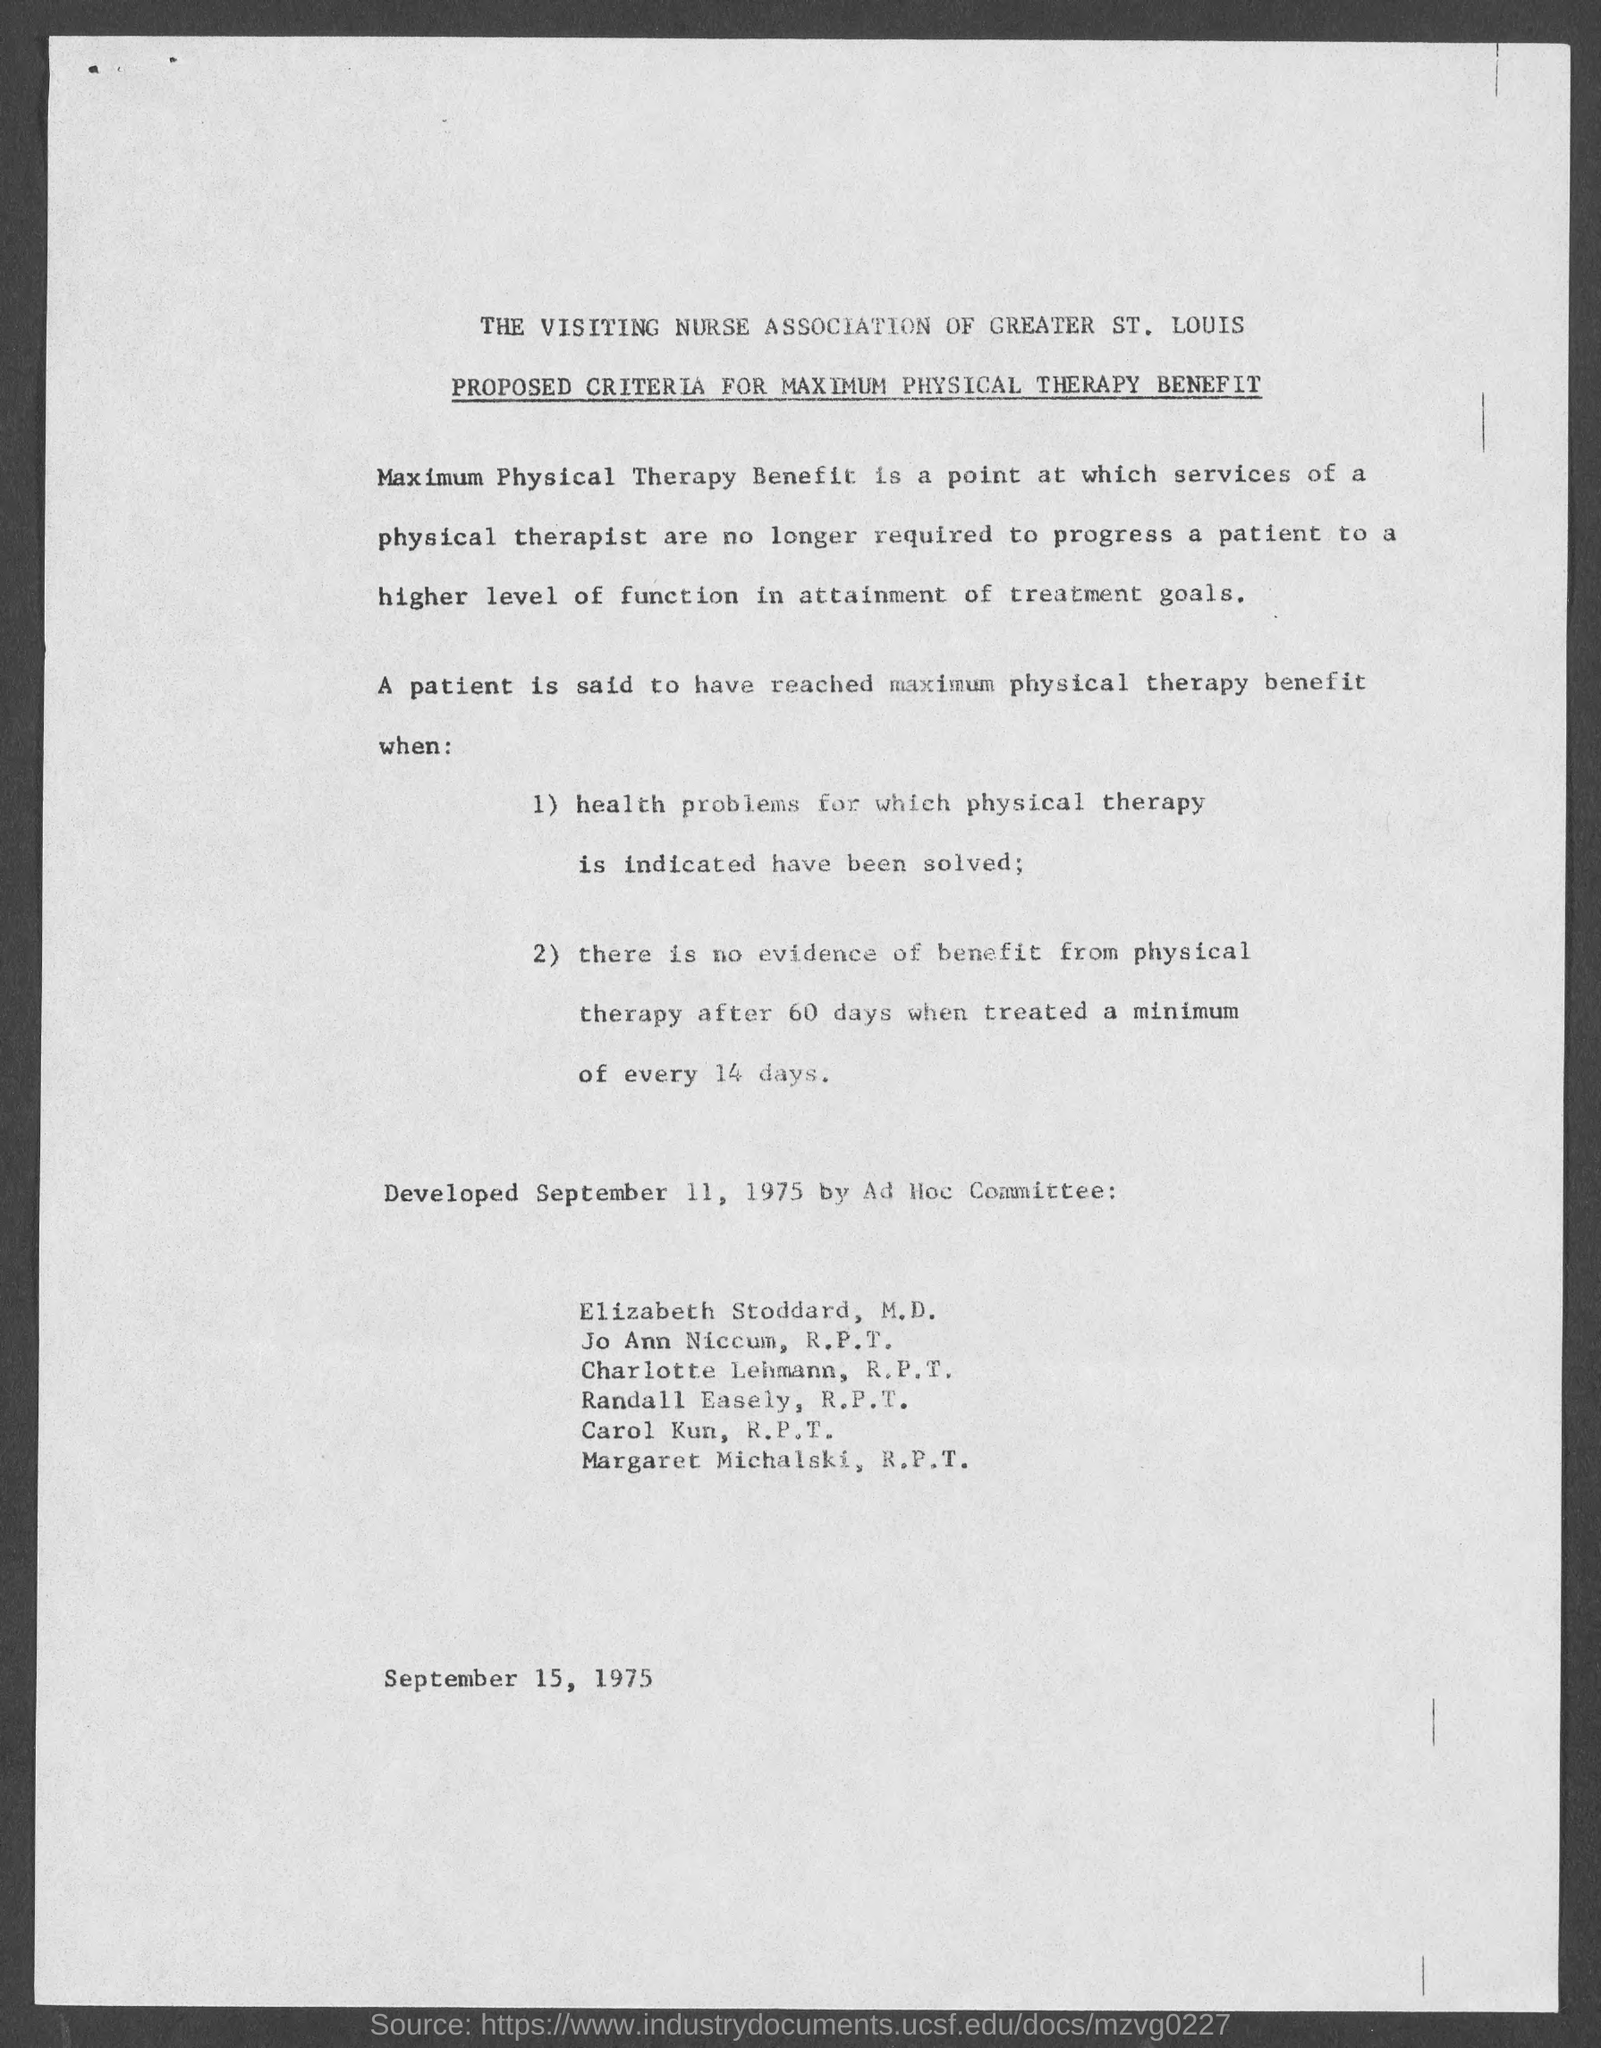Outline some significant characteristics in this image. The issued date of this document is SEPTEMBER 15, 1975. 